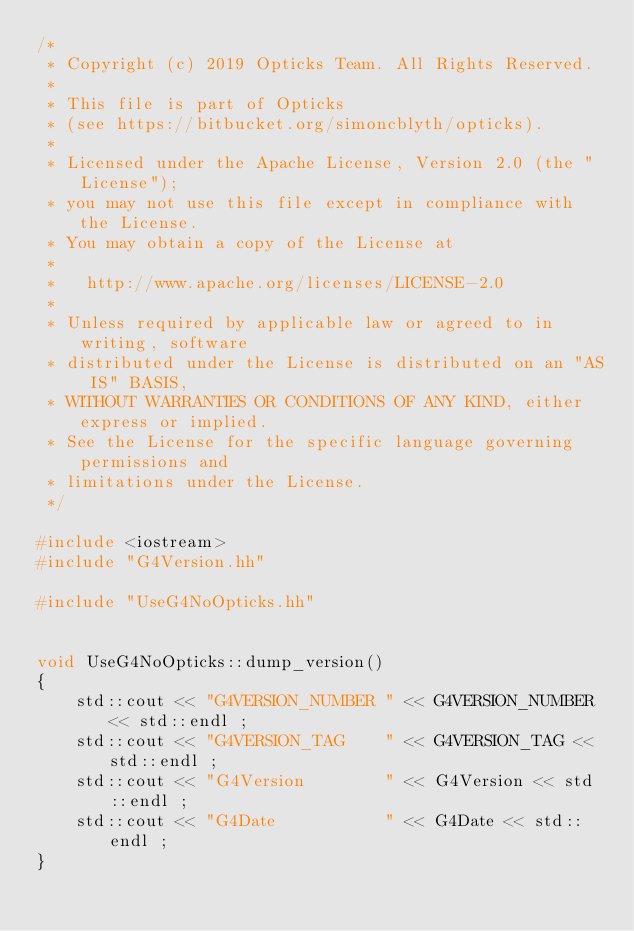<code> <loc_0><loc_0><loc_500><loc_500><_C++_>/*
 * Copyright (c) 2019 Opticks Team. All Rights Reserved.
 *
 * This file is part of Opticks
 * (see https://bitbucket.org/simoncblyth/opticks).
 *
 * Licensed under the Apache License, Version 2.0 (the "License"); 
 * you may not use this file except in compliance with the License.  
 * You may obtain a copy of the License at
 *
 *   http://www.apache.org/licenses/LICENSE-2.0
 *
 * Unless required by applicable law or agreed to in writing, software 
 * distributed under the License is distributed on an "AS IS" BASIS, 
 * WITHOUT WARRANTIES OR CONDITIONS OF ANY KIND, either express or implied.  
 * See the License for the specific language governing permissions and 
 * limitations under the License.
 */

#include <iostream>
#include "G4Version.hh"

#include "UseG4NoOpticks.hh"


void UseG4NoOpticks::dump_version()
{
    std::cout << "G4VERSION_NUMBER " << G4VERSION_NUMBER << std::endl ; 
    std::cout << "G4VERSION_TAG    " << G4VERSION_TAG << std::endl ; 
    std::cout << "G4Version        " << G4Version << std::endl ; 
    std::cout << "G4Date           " << G4Date << std::endl ; 
}


</code> 